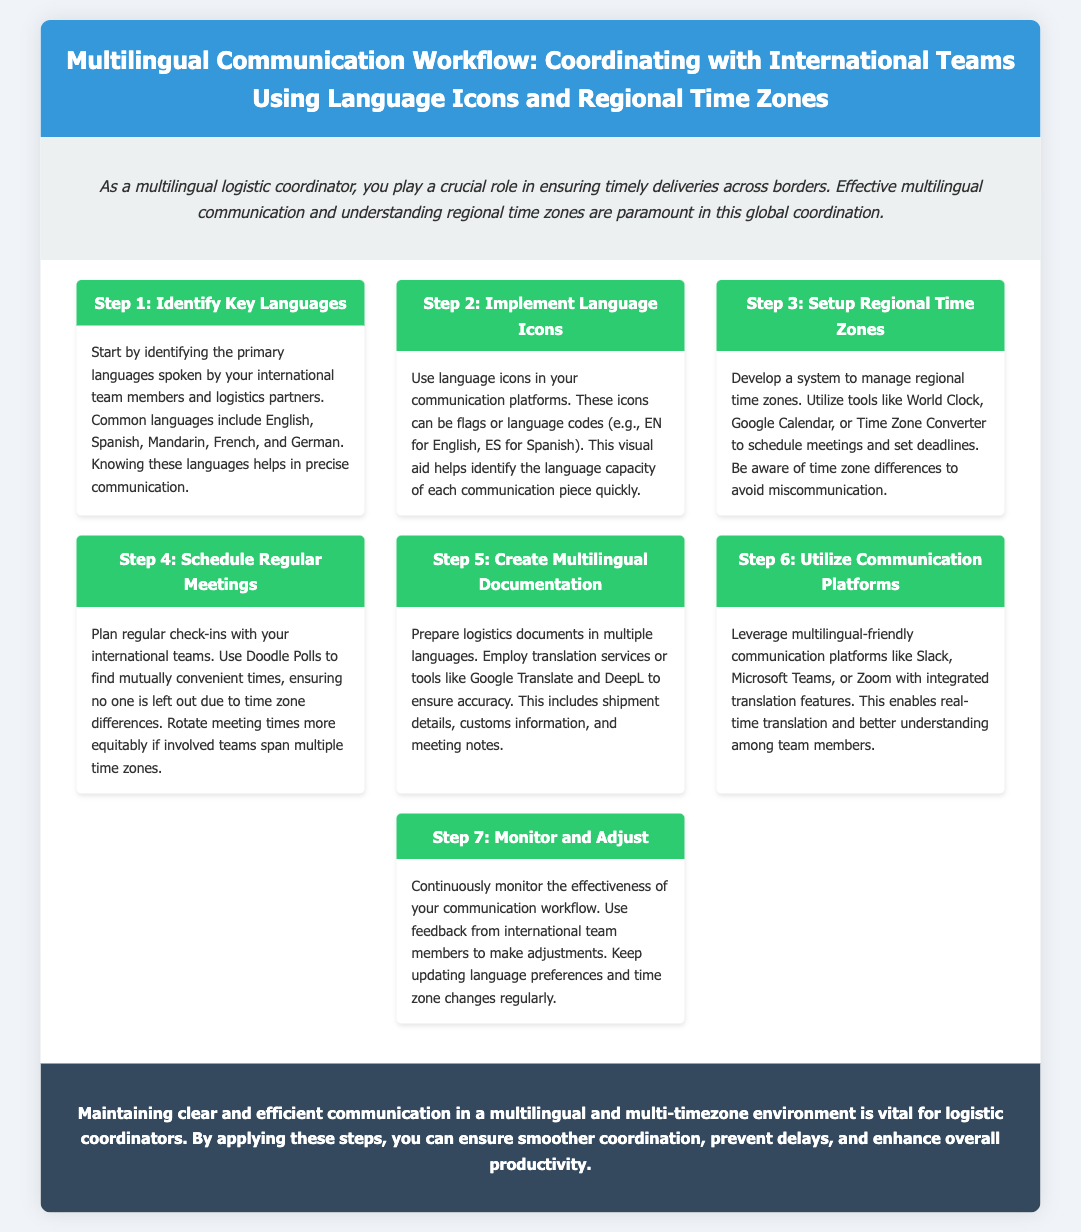What is the title of the document? The title is stated at the beginning of the document, encapsulating the main topic.
Answer: Multilingual Communication Workflow: Coordinating with International Teams Using Language Icons and Regional Time Zones How many steps are outlined in the workflow? The number of steps is mentioned in the document, specifically in the workflow section.
Answer: 7 What is the content of Step 3? Step 3 focuses on the management of time zones, describing the necessary tools and considerations.
Answer: Develop a system to manage regional time zones Which communication platforms are suggested in Step 6? Step 6 lists specific platforms that facilitate multilingual communication among teams.
Answer: Slack, Microsoft Teams, or Zoom What type of meetings should be scheduled regularly? The document specifies the nature of the meetings encouraged for coordination among international teams.
Answer: Regular check-ins What tool is mentioned for scheduling meetings? The document names a specific tool that aids in finding convenient meeting times across different time zones.
Answer: Doodle Polls What should be prepared in multiple languages according to Step 5? Step 5 outlines the documents that need translation to support effective communication.
Answer: Logistics documents 